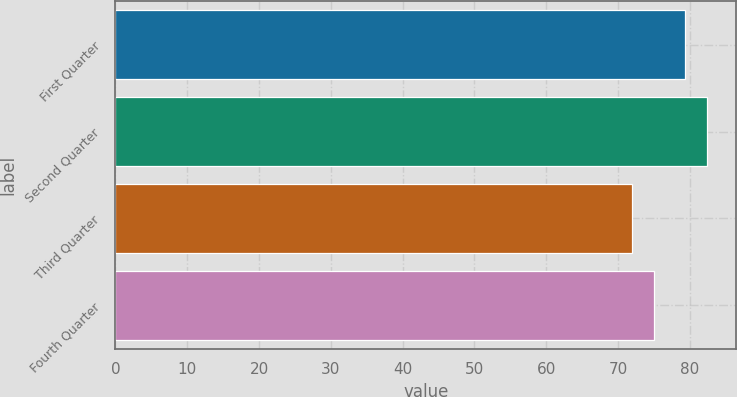<chart> <loc_0><loc_0><loc_500><loc_500><bar_chart><fcel>First Quarter<fcel>Second Quarter<fcel>Third Quarter<fcel>Fourth Quarter<nl><fcel>79.38<fcel>82.33<fcel>71.94<fcel>74.98<nl></chart> 